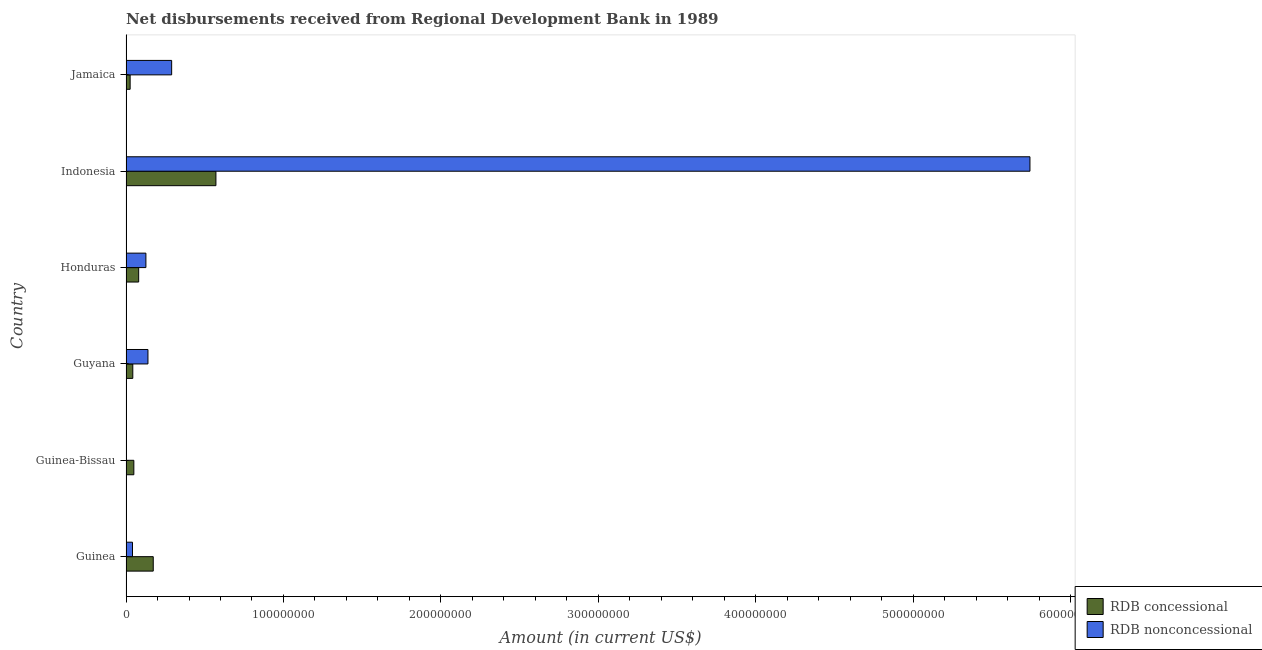How many different coloured bars are there?
Make the answer very short. 2. Are the number of bars per tick equal to the number of legend labels?
Offer a terse response. No. Are the number of bars on each tick of the Y-axis equal?
Your response must be concise. No. What is the net non concessional disbursements from rdb in Jamaica?
Your answer should be compact. 2.90e+07. Across all countries, what is the maximum net non concessional disbursements from rdb?
Keep it short and to the point. 5.74e+08. Across all countries, what is the minimum net concessional disbursements from rdb?
Offer a terse response. 2.62e+06. What is the total net non concessional disbursements from rdb in the graph?
Offer a very short reply. 6.34e+08. What is the difference between the net concessional disbursements from rdb in Guyana and that in Honduras?
Offer a very short reply. -3.74e+06. What is the difference between the net concessional disbursements from rdb in Honduras and the net non concessional disbursements from rdb in Jamaica?
Make the answer very short. -2.09e+07. What is the average net non concessional disbursements from rdb per country?
Give a very brief answer. 1.06e+08. What is the difference between the net concessional disbursements from rdb and net non concessional disbursements from rdb in Indonesia?
Make the answer very short. -5.17e+08. In how many countries, is the net non concessional disbursements from rdb greater than 400000000 US$?
Make the answer very short. 1. What is the ratio of the net concessional disbursements from rdb in Guinea to that in Guyana?
Provide a short and direct response. 4.02. Is the net non concessional disbursements from rdb in Guyana less than that in Indonesia?
Your answer should be compact. Yes. Is the difference between the net concessional disbursements from rdb in Guyana and Jamaica greater than the difference between the net non concessional disbursements from rdb in Guyana and Jamaica?
Your answer should be very brief. Yes. What is the difference between the highest and the second highest net concessional disbursements from rdb?
Provide a short and direct response. 3.98e+07. What is the difference between the highest and the lowest net concessional disbursements from rdb?
Your response must be concise. 5.45e+07. In how many countries, is the net non concessional disbursements from rdb greater than the average net non concessional disbursements from rdb taken over all countries?
Offer a terse response. 1. Is the sum of the net concessional disbursements from rdb in Guinea and Guinea-Bissau greater than the maximum net non concessional disbursements from rdb across all countries?
Your response must be concise. No. How many countries are there in the graph?
Ensure brevity in your answer.  6. What is the difference between two consecutive major ticks on the X-axis?
Your response must be concise. 1.00e+08. Are the values on the major ticks of X-axis written in scientific E-notation?
Offer a terse response. No. How many legend labels are there?
Offer a very short reply. 2. How are the legend labels stacked?
Your answer should be compact. Vertical. What is the title of the graph?
Offer a very short reply. Net disbursements received from Regional Development Bank in 1989. What is the label or title of the Y-axis?
Your answer should be compact. Country. What is the Amount (in current US$) of RDB concessional in Guinea?
Your answer should be compact. 1.73e+07. What is the Amount (in current US$) of RDB nonconcessional in Guinea?
Provide a succinct answer. 4.12e+06. What is the Amount (in current US$) in RDB concessional in Guinea-Bissau?
Ensure brevity in your answer.  4.98e+06. What is the Amount (in current US$) in RDB nonconcessional in Guinea-Bissau?
Make the answer very short. 0. What is the Amount (in current US$) of RDB concessional in Guyana?
Keep it short and to the point. 4.30e+06. What is the Amount (in current US$) in RDB nonconcessional in Guyana?
Provide a succinct answer. 1.39e+07. What is the Amount (in current US$) in RDB concessional in Honduras?
Provide a short and direct response. 8.04e+06. What is the Amount (in current US$) in RDB nonconcessional in Honduras?
Your answer should be very brief. 1.26e+07. What is the Amount (in current US$) in RDB concessional in Indonesia?
Give a very brief answer. 5.71e+07. What is the Amount (in current US$) in RDB nonconcessional in Indonesia?
Ensure brevity in your answer.  5.74e+08. What is the Amount (in current US$) of RDB concessional in Jamaica?
Your answer should be very brief. 2.62e+06. What is the Amount (in current US$) of RDB nonconcessional in Jamaica?
Give a very brief answer. 2.90e+07. Across all countries, what is the maximum Amount (in current US$) of RDB concessional?
Your answer should be very brief. 5.71e+07. Across all countries, what is the maximum Amount (in current US$) of RDB nonconcessional?
Offer a very short reply. 5.74e+08. Across all countries, what is the minimum Amount (in current US$) of RDB concessional?
Make the answer very short. 2.62e+06. What is the total Amount (in current US$) of RDB concessional in the graph?
Your answer should be very brief. 9.43e+07. What is the total Amount (in current US$) of RDB nonconcessional in the graph?
Offer a terse response. 6.34e+08. What is the difference between the Amount (in current US$) of RDB concessional in Guinea and that in Guinea-Bissau?
Keep it short and to the point. 1.23e+07. What is the difference between the Amount (in current US$) in RDB concessional in Guinea and that in Guyana?
Keep it short and to the point. 1.30e+07. What is the difference between the Amount (in current US$) in RDB nonconcessional in Guinea and that in Guyana?
Provide a succinct answer. -9.82e+06. What is the difference between the Amount (in current US$) of RDB concessional in Guinea and that in Honduras?
Offer a very short reply. 9.25e+06. What is the difference between the Amount (in current US$) in RDB nonconcessional in Guinea and that in Honduras?
Offer a very short reply. -8.51e+06. What is the difference between the Amount (in current US$) of RDB concessional in Guinea and that in Indonesia?
Your answer should be very brief. -3.98e+07. What is the difference between the Amount (in current US$) of RDB nonconcessional in Guinea and that in Indonesia?
Give a very brief answer. -5.70e+08. What is the difference between the Amount (in current US$) of RDB concessional in Guinea and that in Jamaica?
Make the answer very short. 1.47e+07. What is the difference between the Amount (in current US$) in RDB nonconcessional in Guinea and that in Jamaica?
Keep it short and to the point. -2.49e+07. What is the difference between the Amount (in current US$) of RDB concessional in Guinea-Bissau and that in Guyana?
Offer a terse response. 6.74e+05. What is the difference between the Amount (in current US$) of RDB concessional in Guinea-Bissau and that in Honduras?
Offer a very short reply. -3.06e+06. What is the difference between the Amount (in current US$) of RDB concessional in Guinea-Bissau and that in Indonesia?
Your answer should be very brief. -5.21e+07. What is the difference between the Amount (in current US$) in RDB concessional in Guinea-Bissau and that in Jamaica?
Keep it short and to the point. 2.36e+06. What is the difference between the Amount (in current US$) in RDB concessional in Guyana and that in Honduras?
Your answer should be very brief. -3.74e+06. What is the difference between the Amount (in current US$) in RDB nonconcessional in Guyana and that in Honduras?
Make the answer very short. 1.30e+06. What is the difference between the Amount (in current US$) of RDB concessional in Guyana and that in Indonesia?
Give a very brief answer. -5.28e+07. What is the difference between the Amount (in current US$) of RDB nonconcessional in Guyana and that in Indonesia?
Offer a very short reply. -5.60e+08. What is the difference between the Amount (in current US$) in RDB concessional in Guyana and that in Jamaica?
Give a very brief answer. 1.68e+06. What is the difference between the Amount (in current US$) in RDB nonconcessional in Guyana and that in Jamaica?
Ensure brevity in your answer.  -1.51e+07. What is the difference between the Amount (in current US$) in RDB concessional in Honduras and that in Indonesia?
Offer a very short reply. -4.91e+07. What is the difference between the Amount (in current US$) in RDB nonconcessional in Honduras and that in Indonesia?
Give a very brief answer. -5.61e+08. What is the difference between the Amount (in current US$) in RDB concessional in Honduras and that in Jamaica?
Your response must be concise. 5.42e+06. What is the difference between the Amount (in current US$) in RDB nonconcessional in Honduras and that in Jamaica?
Provide a succinct answer. -1.64e+07. What is the difference between the Amount (in current US$) in RDB concessional in Indonesia and that in Jamaica?
Make the answer very short. 5.45e+07. What is the difference between the Amount (in current US$) in RDB nonconcessional in Indonesia and that in Jamaica?
Your response must be concise. 5.45e+08. What is the difference between the Amount (in current US$) in RDB concessional in Guinea and the Amount (in current US$) in RDB nonconcessional in Guyana?
Your answer should be very brief. 3.36e+06. What is the difference between the Amount (in current US$) of RDB concessional in Guinea and the Amount (in current US$) of RDB nonconcessional in Honduras?
Offer a terse response. 4.66e+06. What is the difference between the Amount (in current US$) of RDB concessional in Guinea and the Amount (in current US$) of RDB nonconcessional in Indonesia?
Give a very brief answer. -5.57e+08. What is the difference between the Amount (in current US$) in RDB concessional in Guinea and the Amount (in current US$) in RDB nonconcessional in Jamaica?
Make the answer very short. -1.17e+07. What is the difference between the Amount (in current US$) of RDB concessional in Guinea-Bissau and the Amount (in current US$) of RDB nonconcessional in Guyana?
Offer a very short reply. -8.96e+06. What is the difference between the Amount (in current US$) of RDB concessional in Guinea-Bissau and the Amount (in current US$) of RDB nonconcessional in Honduras?
Your response must be concise. -7.65e+06. What is the difference between the Amount (in current US$) of RDB concessional in Guinea-Bissau and the Amount (in current US$) of RDB nonconcessional in Indonesia?
Your answer should be very brief. -5.69e+08. What is the difference between the Amount (in current US$) in RDB concessional in Guinea-Bissau and the Amount (in current US$) in RDB nonconcessional in Jamaica?
Make the answer very short. -2.40e+07. What is the difference between the Amount (in current US$) of RDB concessional in Guyana and the Amount (in current US$) of RDB nonconcessional in Honduras?
Offer a terse response. -8.33e+06. What is the difference between the Amount (in current US$) in RDB concessional in Guyana and the Amount (in current US$) in RDB nonconcessional in Indonesia?
Your answer should be very brief. -5.70e+08. What is the difference between the Amount (in current US$) of RDB concessional in Guyana and the Amount (in current US$) of RDB nonconcessional in Jamaica?
Provide a succinct answer. -2.47e+07. What is the difference between the Amount (in current US$) in RDB concessional in Honduras and the Amount (in current US$) in RDB nonconcessional in Indonesia?
Your answer should be compact. -5.66e+08. What is the difference between the Amount (in current US$) in RDB concessional in Honduras and the Amount (in current US$) in RDB nonconcessional in Jamaica?
Provide a short and direct response. -2.09e+07. What is the difference between the Amount (in current US$) in RDB concessional in Indonesia and the Amount (in current US$) in RDB nonconcessional in Jamaica?
Offer a very short reply. 2.81e+07. What is the average Amount (in current US$) in RDB concessional per country?
Give a very brief answer. 1.57e+07. What is the average Amount (in current US$) of RDB nonconcessional per country?
Keep it short and to the point. 1.06e+08. What is the difference between the Amount (in current US$) of RDB concessional and Amount (in current US$) of RDB nonconcessional in Guinea?
Your answer should be compact. 1.32e+07. What is the difference between the Amount (in current US$) of RDB concessional and Amount (in current US$) of RDB nonconcessional in Guyana?
Offer a very short reply. -9.63e+06. What is the difference between the Amount (in current US$) of RDB concessional and Amount (in current US$) of RDB nonconcessional in Honduras?
Provide a short and direct response. -4.59e+06. What is the difference between the Amount (in current US$) of RDB concessional and Amount (in current US$) of RDB nonconcessional in Indonesia?
Make the answer very short. -5.17e+08. What is the difference between the Amount (in current US$) in RDB concessional and Amount (in current US$) in RDB nonconcessional in Jamaica?
Your response must be concise. -2.64e+07. What is the ratio of the Amount (in current US$) in RDB concessional in Guinea to that in Guinea-Bissau?
Your response must be concise. 3.47. What is the ratio of the Amount (in current US$) of RDB concessional in Guinea to that in Guyana?
Make the answer very short. 4.02. What is the ratio of the Amount (in current US$) of RDB nonconcessional in Guinea to that in Guyana?
Provide a short and direct response. 0.3. What is the ratio of the Amount (in current US$) of RDB concessional in Guinea to that in Honduras?
Your answer should be compact. 2.15. What is the ratio of the Amount (in current US$) in RDB nonconcessional in Guinea to that in Honduras?
Your answer should be very brief. 0.33. What is the ratio of the Amount (in current US$) of RDB concessional in Guinea to that in Indonesia?
Make the answer very short. 0.3. What is the ratio of the Amount (in current US$) of RDB nonconcessional in Guinea to that in Indonesia?
Your response must be concise. 0.01. What is the ratio of the Amount (in current US$) of RDB concessional in Guinea to that in Jamaica?
Offer a terse response. 6.6. What is the ratio of the Amount (in current US$) in RDB nonconcessional in Guinea to that in Jamaica?
Your answer should be compact. 0.14. What is the ratio of the Amount (in current US$) of RDB concessional in Guinea-Bissau to that in Guyana?
Make the answer very short. 1.16. What is the ratio of the Amount (in current US$) of RDB concessional in Guinea-Bissau to that in Honduras?
Your response must be concise. 0.62. What is the ratio of the Amount (in current US$) in RDB concessional in Guinea-Bissau to that in Indonesia?
Ensure brevity in your answer.  0.09. What is the ratio of the Amount (in current US$) of RDB concessional in Guinea-Bissau to that in Jamaica?
Keep it short and to the point. 1.9. What is the ratio of the Amount (in current US$) of RDB concessional in Guyana to that in Honduras?
Keep it short and to the point. 0.54. What is the ratio of the Amount (in current US$) of RDB nonconcessional in Guyana to that in Honduras?
Provide a short and direct response. 1.1. What is the ratio of the Amount (in current US$) of RDB concessional in Guyana to that in Indonesia?
Keep it short and to the point. 0.08. What is the ratio of the Amount (in current US$) in RDB nonconcessional in Guyana to that in Indonesia?
Keep it short and to the point. 0.02. What is the ratio of the Amount (in current US$) of RDB concessional in Guyana to that in Jamaica?
Ensure brevity in your answer.  1.64. What is the ratio of the Amount (in current US$) of RDB nonconcessional in Guyana to that in Jamaica?
Your answer should be very brief. 0.48. What is the ratio of the Amount (in current US$) of RDB concessional in Honduras to that in Indonesia?
Offer a terse response. 0.14. What is the ratio of the Amount (in current US$) in RDB nonconcessional in Honduras to that in Indonesia?
Your answer should be compact. 0.02. What is the ratio of the Amount (in current US$) of RDB concessional in Honduras to that in Jamaica?
Your answer should be compact. 3.07. What is the ratio of the Amount (in current US$) in RDB nonconcessional in Honduras to that in Jamaica?
Your response must be concise. 0.44. What is the ratio of the Amount (in current US$) of RDB concessional in Indonesia to that in Jamaica?
Your answer should be compact. 21.78. What is the ratio of the Amount (in current US$) in RDB nonconcessional in Indonesia to that in Jamaica?
Offer a very short reply. 19.8. What is the difference between the highest and the second highest Amount (in current US$) of RDB concessional?
Provide a short and direct response. 3.98e+07. What is the difference between the highest and the second highest Amount (in current US$) in RDB nonconcessional?
Your response must be concise. 5.45e+08. What is the difference between the highest and the lowest Amount (in current US$) of RDB concessional?
Give a very brief answer. 5.45e+07. What is the difference between the highest and the lowest Amount (in current US$) of RDB nonconcessional?
Ensure brevity in your answer.  5.74e+08. 